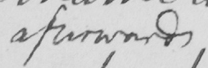Please provide the text content of this handwritten line. afterwards 